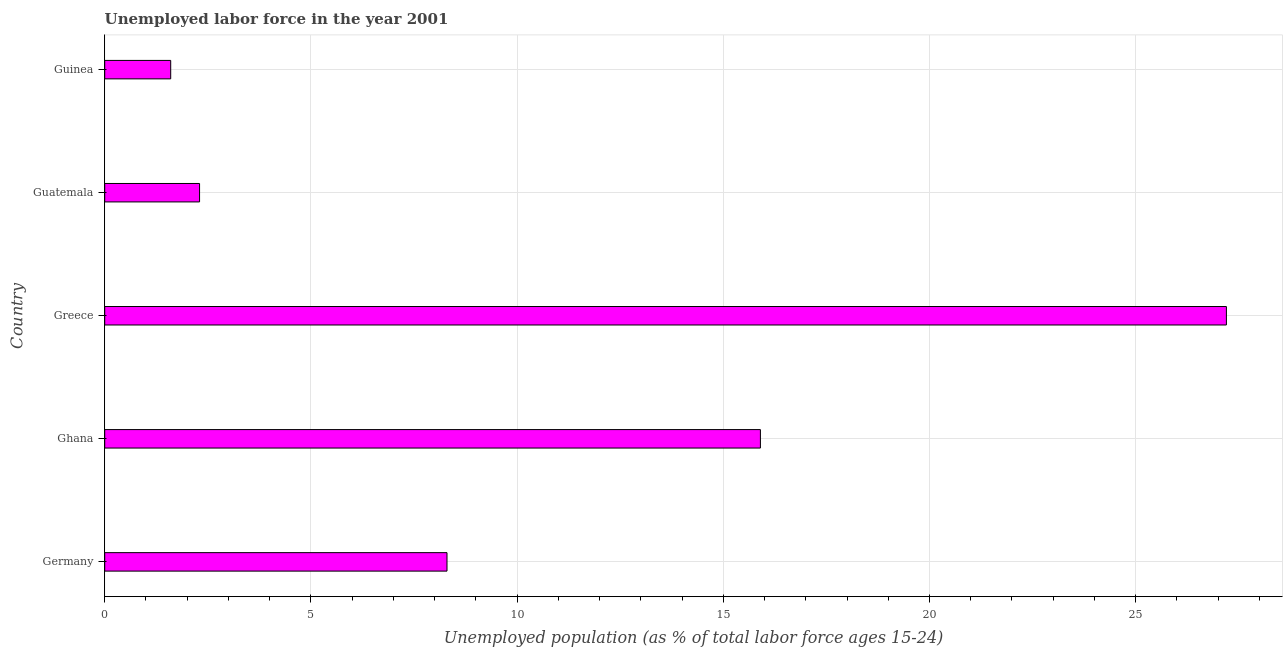What is the title of the graph?
Keep it short and to the point. Unemployed labor force in the year 2001. What is the label or title of the X-axis?
Provide a succinct answer. Unemployed population (as % of total labor force ages 15-24). What is the label or title of the Y-axis?
Provide a short and direct response. Country. What is the total unemployed youth population in Ghana?
Provide a succinct answer. 15.9. Across all countries, what is the maximum total unemployed youth population?
Ensure brevity in your answer.  27.2. Across all countries, what is the minimum total unemployed youth population?
Give a very brief answer. 1.6. In which country was the total unemployed youth population minimum?
Your answer should be very brief. Guinea. What is the sum of the total unemployed youth population?
Keep it short and to the point. 55.3. What is the difference between the total unemployed youth population in Germany and Ghana?
Give a very brief answer. -7.6. What is the average total unemployed youth population per country?
Offer a terse response. 11.06. What is the median total unemployed youth population?
Offer a very short reply. 8.3. What is the ratio of the total unemployed youth population in Germany to that in Guatemala?
Keep it short and to the point. 3.61. Is the total unemployed youth population in Germany less than that in Guinea?
Make the answer very short. No. Is the sum of the total unemployed youth population in Germany and Ghana greater than the maximum total unemployed youth population across all countries?
Ensure brevity in your answer.  No. What is the difference between the highest and the lowest total unemployed youth population?
Ensure brevity in your answer.  25.6. In how many countries, is the total unemployed youth population greater than the average total unemployed youth population taken over all countries?
Offer a terse response. 2. How many countries are there in the graph?
Provide a succinct answer. 5. What is the difference between two consecutive major ticks on the X-axis?
Your answer should be compact. 5. What is the Unemployed population (as % of total labor force ages 15-24) of Germany?
Your answer should be compact. 8.3. What is the Unemployed population (as % of total labor force ages 15-24) of Ghana?
Offer a very short reply. 15.9. What is the Unemployed population (as % of total labor force ages 15-24) in Greece?
Your answer should be compact. 27.2. What is the Unemployed population (as % of total labor force ages 15-24) of Guatemala?
Your answer should be very brief. 2.3. What is the Unemployed population (as % of total labor force ages 15-24) in Guinea?
Keep it short and to the point. 1.6. What is the difference between the Unemployed population (as % of total labor force ages 15-24) in Germany and Ghana?
Provide a short and direct response. -7.6. What is the difference between the Unemployed population (as % of total labor force ages 15-24) in Germany and Greece?
Provide a short and direct response. -18.9. What is the difference between the Unemployed population (as % of total labor force ages 15-24) in Ghana and Greece?
Your answer should be compact. -11.3. What is the difference between the Unemployed population (as % of total labor force ages 15-24) in Ghana and Guinea?
Your response must be concise. 14.3. What is the difference between the Unemployed population (as % of total labor force ages 15-24) in Greece and Guatemala?
Offer a terse response. 24.9. What is the difference between the Unemployed population (as % of total labor force ages 15-24) in Greece and Guinea?
Provide a succinct answer. 25.6. What is the difference between the Unemployed population (as % of total labor force ages 15-24) in Guatemala and Guinea?
Offer a terse response. 0.7. What is the ratio of the Unemployed population (as % of total labor force ages 15-24) in Germany to that in Ghana?
Provide a succinct answer. 0.52. What is the ratio of the Unemployed population (as % of total labor force ages 15-24) in Germany to that in Greece?
Provide a succinct answer. 0.3. What is the ratio of the Unemployed population (as % of total labor force ages 15-24) in Germany to that in Guatemala?
Keep it short and to the point. 3.61. What is the ratio of the Unemployed population (as % of total labor force ages 15-24) in Germany to that in Guinea?
Provide a short and direct response. 5.19. What is the ratio of the Unemployed population (as % of total labor force ages 15-24) in Ghana to that in Greece?
Provide a succinct answer. 0.58. What is the ratio of the Unemployed population (as % of total labor force ages 15-24) in Ghana to that in Guatemala?
Offer a terse response. 6.91. What is the ratio of the Unemployed population (as % of total labor force ages 15-24) in Ghana to that in Guinea?
Offer a very short reply. 9.94. What is the ratio of the Unemployed population (as % of total labor force ages 15-24) in Greece to that in Guatemala?
Give a very brief answer. 11.83. What is the ratio of the Unemployed population (as % of total labor force ages 15-24) in Guatemala to that in Guinea?
Your response must be concise. 1.44. 